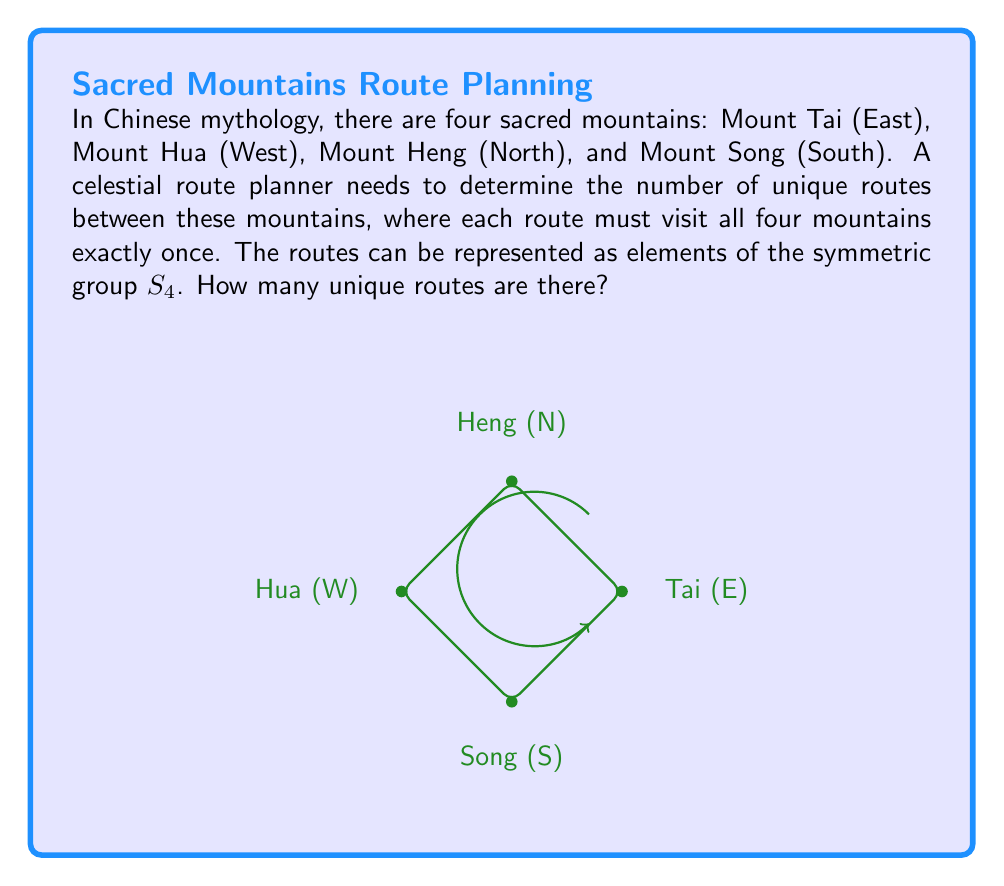Give your solution to this math problem. Let's approach this step-by-step using group theory:

1) The routes can be represented as permutations of the four mountains. This corresponds to elements of the symmetric group $S_4$.

2) In $S_4$, each element represents a unique way to order the four mountains.

3) The order of $S_4$ (i.e., the number of elements in the group) is given by $4!$ (4 factorial).

4) To calculate $4!$:
   $$4! = 4 \times 3 \times 2 \times 1 = 24$$

5) Each element of $S_4$ corresponds to a unique route visiting all four mountains exactly once.

6) Therefore, the number of unique routes is equal to the order of $S_4$, which is 24.

This result aligns with the Chinese mythological concept of completeness and balance, as 24 is a number often associated with completeness in Chinese culture (24 solar terms in a year, 24 hours in a day).
Answer: 24 